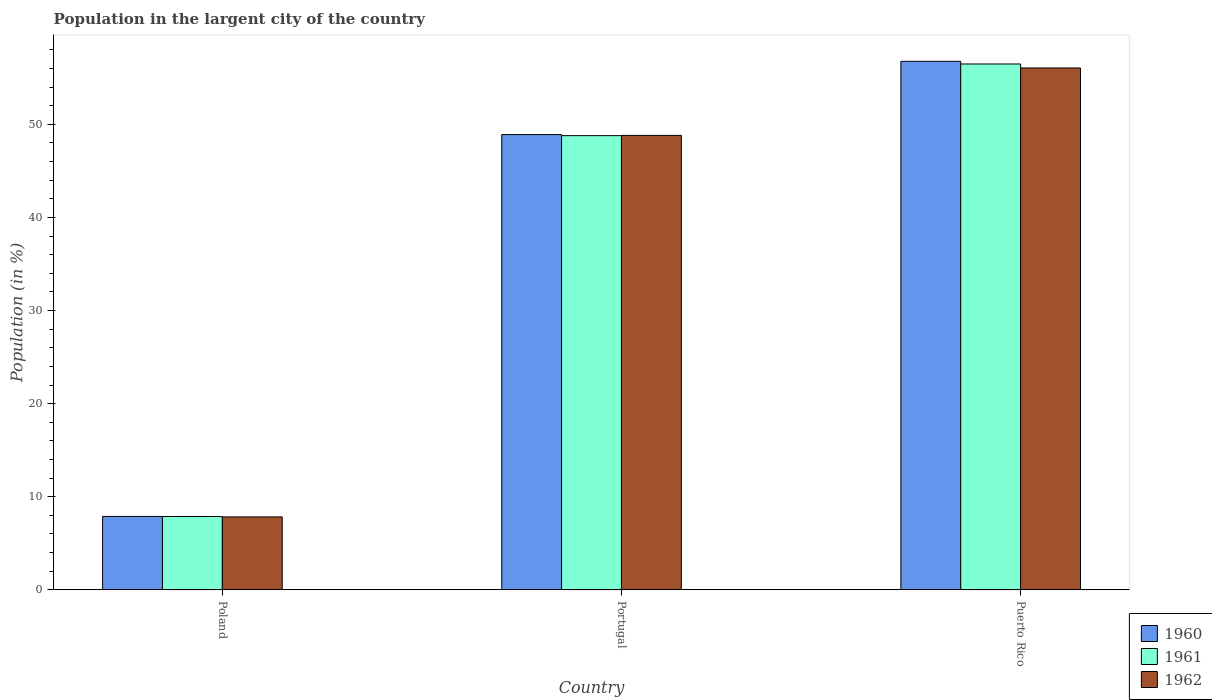Are the number of bars per tick equal to the number of legend labels?
Ensure brevity in your answer.  Yes. How many bars are there on the 2nd tick from the right?
Provide a succinct answer. 3. What is the label of the 2nd group of bars from the left?
Offer a terse response. Portugal. What is the percentage of population in the largent city in 1960 in Portugal?
Ensure brevity in your answer.  48.89. Across all countries, what is the maximum percentage of population in the largent city in 1960?
Provide a succinct answer. 56.77. Across all countries, what is the minimum percentage of population in the largent city in 1960?
Keep it short and to the point. 7.88. In which country was the percentage of population in the largent city in 1962 maximum?
Your answer should be compact. Puerto Rico. What is the total percentage of population in the largent city in 1961 in the graph?
Offer a very short reply. 113.13. What is the difference between the percentage of population in the largent city in 1960 in Poland and that in Puerto Rico?
Your answer should be compact. -48.88. What is the difference between the percentage of population in the largent city in 1961 in Portugal and the percentage of population in the largent city in 1962 in Poland?
Provide a short and direct response. 40.95. What is the average percentage of population in the largent city in 1960 per country?
Give a very brief answer. 37.85. What is the difference between the percentage of population in the largent city of/in 1960 and percentage of population in the largent city of/in 1962 in Poland?
Offer a terse response. 0.05. In how many countries, is the percentage of population in the largent city in 1960 greater than 44 %?
Offer a very short reply. 2. What is the ratio of the percentage of population in the largent city in 1960 in Poland to that in Puerto Rico?
Give a very brief answer. 0.14. What is the difference between the highest and the second highest percentage of population in the largent city in 1960?
Make the answer very short. 7.87. What is the difference between the highest and the lowest percentage of population in the largent city in 1961?
Offer a terse response. 48.6. In how many countries, is the percentage of population in the largent city in 1962 greater than the average percentage of population in the largent city in 1962 taken over all countries?
Make the answer very short. 2. Is it the case that in every country, the sum of the percentage of population in the largent city in 1961 and percentage of population in the largent city in 1962 is greater than the percentage of population in the largent city in 1960?
Your answer should be compact. Yes. How many countries are there in the graph?
Offer a very short reply. 3. What is the difference between two consecutive major ticks on the Y-axis?
Ensure brevity in your answer.  10. Does the graph contain any zero values?
Your answer should be very brief. No. Does the graph contain grids?
Provide a succinct answer. No. How are the legend labels stacked?
Offer a very short reply. Vertical. What is the title of the graph?
Your answer should be compact. Population in the largent city of the country. What is the Population (in %) of 1960 in Poland?
Offer a very short reply. 7.88. What is the Population (in %) in 1961 in Poland?
Make the answer very short. 7.88. What is the Population (in %) in 1962 in Poland?
Provide a succinct answer. 7.83. What is the Population (in %) in 1960 in Portugal?
Provide a short and direct response. 48.89. What is the Population (in %) of 1961 in Portugal?
Offer a terse response. 48.78. What is the Population (in %) in 1962 in Portugal?
Give a very brief answer. 48.81. What is the Population (in %) in 1960 in Puerto Rico?
Keep it short and to the point. 56.77. What is the Population (in %) of 1961 in Puerto Rico?
Provide a short and direct response. 56.48. What is the Population (in %) of 1962 in Puerto Rico?
Provide a short and direct response. 56.05. Across all countries, what is the maximum Population (in %) in 1960?
Your answer should be compact. 56.77. Across all countries, what is the maximum Population (in %) in 1961?
Ensure brevity in your answer.  56.48. Across all countries, what is the maximum Population (in %) in 1962?
Provide a short and direct response. 56.05. Across all countries, what is the minimum Population (in %) of 1960?
Provide a succinct answer. 7.88. Across all countries, what is the minimum Population (in %) of 1961?
Give a very brief answer. 7.88. Across all countries, what is the minimum Population (in %) in 1962?
Your answer should be compact. 7.83. What is the total Population (in %) in 1960 in the graph?
Provide a short and direct response. 113.54. What is the total Population (in %) of 1961 in the graph?
Provide a short and direct response. 113.13. What is the total Population (in %) in 1962 in the graph?
Give a very brief answer. 112.69. What is the difference between the Population (in %) of 1960 in Poland and that in Portugal?
Your answer should be very brief. -41.01. What is the difference between the Population (in %) of 1961 in Poland and that in Portugal?
Provide a succinct answer. -40.91. What is the difference between the Population (in %) of 1962 in Poland and that in Portugal?
Provide a succinct answer. -40.97. What is the difference between the Population (in %) of 1960 in Poland and that in Puerto Rico?
Provide a succinct answer. -48.88. What is the difference between the Population (in %) in 1961 in Poland and that in Puerto Rico?
Provide a short and direct response. -48.6. What is the difference between the Population (in %) in 1962 in Poland and that in Puerto Rico?
Keep it short and to the point. -48.22. What is the difference between the Population (in %) in 1960 in Portugal and that in Puerto Rico?
Your answer should be very brief. -7.87. What is the difference between the Population (in %) of 1961 in Portugal and that in Puerto Rico?
Provide a short and direct response. -7.7. What is the difference between the Population (in %) of 1962 in Portugal and that in Puerto Rico?
Provide a succinct answer. -7.24. What is the difference between the Population (in %) of 1960 in Poland and the Population (in %) of 1961 in Portugal?
Provide a short and direct response. -40.9. What is the difference between the Population (in %) of 1960 in Poland and the Population (in %) of 1962 in Portugal?
Provide a succinct answer. -40.92. What is the difference between the Population (in %) of 1961 in Poland and the Population (in %) of 1962 in Portugal?
Your response must be concise. -40.93. What is the difference between the Population (in %) in 1960 in Poland and the Population (in %) in 1961 in Puerto Rico?
Give a very brief answer. -48.59. What is the difference between the Population (in %) in 1960 in Poland and the Population (in %) in 1962 in Puerto Rico?
Provide a short and direct response. -48.17. What is the difference between the Population (in %) of 1961 in Poland and the Population (in %) of 1962 in Puerto Rico?
Provide a short and direct response. -48.18. What is the difference between the Population (in %) in 1960 in Portugal and the Population (in %) in 1961 in Puerto Rico?
Make the answer very short. -7.58. What is the difference between the Population (in %) of 1960 in Portugal and the Population (in %) of 1962 in Puerto Rico?
Provide a short and direct response. -7.16. What is the difference between the Population (in %) in 1961 in Portugal and the Population (in %) in 1962 in Puerto Rico?
Make the answer very short. -7.27. What is the average Population (in %) of 1960 per country?
Your answer should be very brief. 37.85. What is the average Population (in %) of 1961 per country?
Your response must be concise. 37.71. What is the average Population (in %) of 1962 per country?
Offer a very short reply. 37.56. What is the difference between the Population (in %) in 1960 and Population (in %) in 1961 in Poland?
Provide a short and direct response. 0.01. What is the difference between the Population (in %) of 1960 and Population (in %) of 1962 in Poland?
Provide a short and direct response. 0.05. What is the difference between the Population (in %) in 1961 and Population (in %) in 1962 in Poland?
Provide a succinct answer. 0.04. What is the difference between the Population (in %) in 1960 and Population (in %) in 1961 in Portugal?
Offer a very short reply. 0.11. What is the difference between the Population (in %) of 1960 and Population (in %) of 1962 in Portugal?
Offer a terse response. 0.09. What is the difference between the Population (in %) of 1961 and Population (in %) of 1962 in Portugal?
Your answer should be compact. -0.03. What is the difference between the Population (in %) of 1960 and Population (in %) of 1961 in Puerto Rico?
Ensure brevity in your answer.  0.29. What is the difference between the Population (in %) of 1960 and Population (in %) of 1962 in Puerto Rico?
Give a very brief answer. 0.71. What is the difference between the Population (in %) in 1961 and Population (in %) in 1962 in Puerto Rico?
Your response must be concise. 0.43. What is the ratio of the Population (in %) in 1960 in Poland to that in Portugal?
Give a very brief answer. 0.16. What is the ratio of the Population (in %) of 1961 in Poland to that in Portugal?
Offer a very short reply. 0.16. What is the ratio of the Population (in %) in 1962 in Poland to that in Portugal?
Provide a succinct answer. 0.16. What is the ratio of the Population (in %) of 1960 in Poland to that in Puerto Rico?
Offer a very short reply. 0.14. What is the ratio of the Population (in %) in 1961 in Poland to that in Puerto Rico?
Provide a short and direct response. 0.14. What is the ratio of the Population (in %) in 1962 in Poland to that in Puerto Rico?
Keep it short and to the point. 0.14. What is the ratio of the Population (in %) of 1960 in Portugal to that in Puerto Rico?
Provide a succinct answer. 0.86. What is the ratio of the Population (in %) of 1961 in Portugal to that in Puerto Rico?
Ensure brevity in your answer.  0.86. What is the ratio of the Population (in %) in 1962 in Portugal to that in Puerto Rico?
Your answer should be very brief. 0.87. What is the difference between the highest and the second highest Population (in %) in 1960?
Your answer should be very brief. 7.87. What is the difference between the highest and the second highest Population (in %) in 1961?
Make the answer very short. 7.7. What is the difference between the highest and the second highest Population (in %) of 1962?
Give a very brief answer. 7.24. What is the difference between the highest and the lowest Population (in %) of 1960?
Your answer should be very brief. 48.88. What is the difference between the highest and the lowest Population (in %) in 1961?
Your answer should be compact. 48.6. What is the difference between the highest and the lowest Population (in %) of 1962?
Offer a terse response. 48.22. 